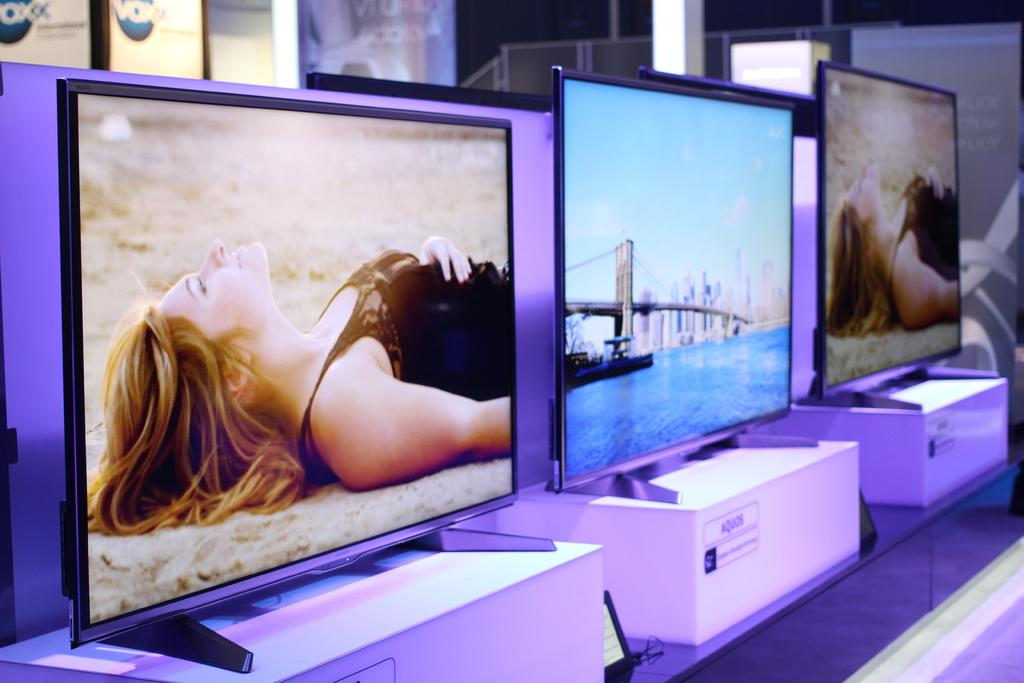Provide a one-sentence caption for the provided image. An assortment of televisions are displayed in a VOXX show room. 